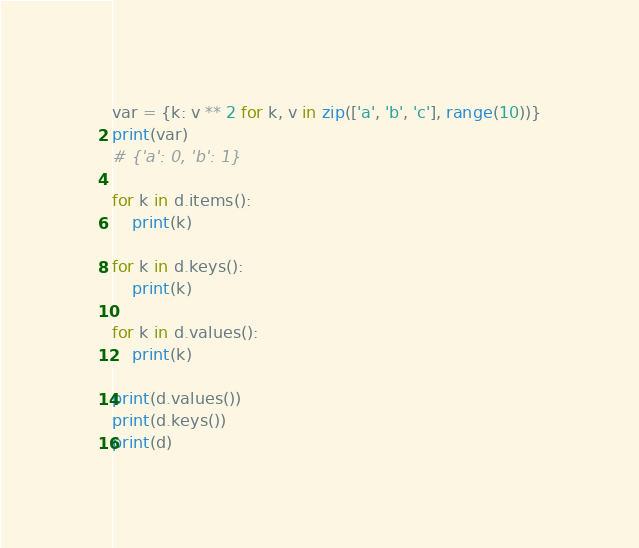Convert code to text. <code><loc_0><loc_0><loc_500><loc_500><_Python_>
var = {k: v ** 2 for k, v in zip(['a', 'b', 'c'], range(10))}
print(var)
# {'a': 0, 'b': 1}

for k in d.items():
    print(k)

for k in d.keys():
    print(k)

for k in d.values():
    print(k)

print(d.values())
print(d.keys())
print(d)

</code> 